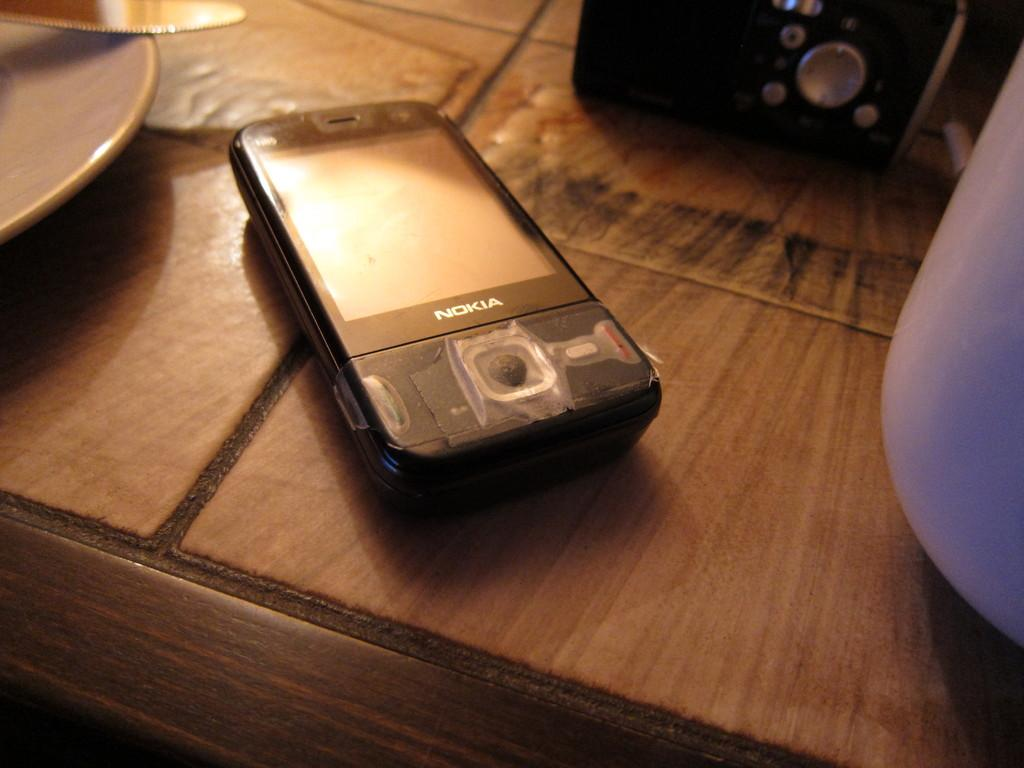<image>
Create a compact narrative representing the image presented. A Nokia smartphone with cellophane tape covering the home button laying on a tiel covered counter. 